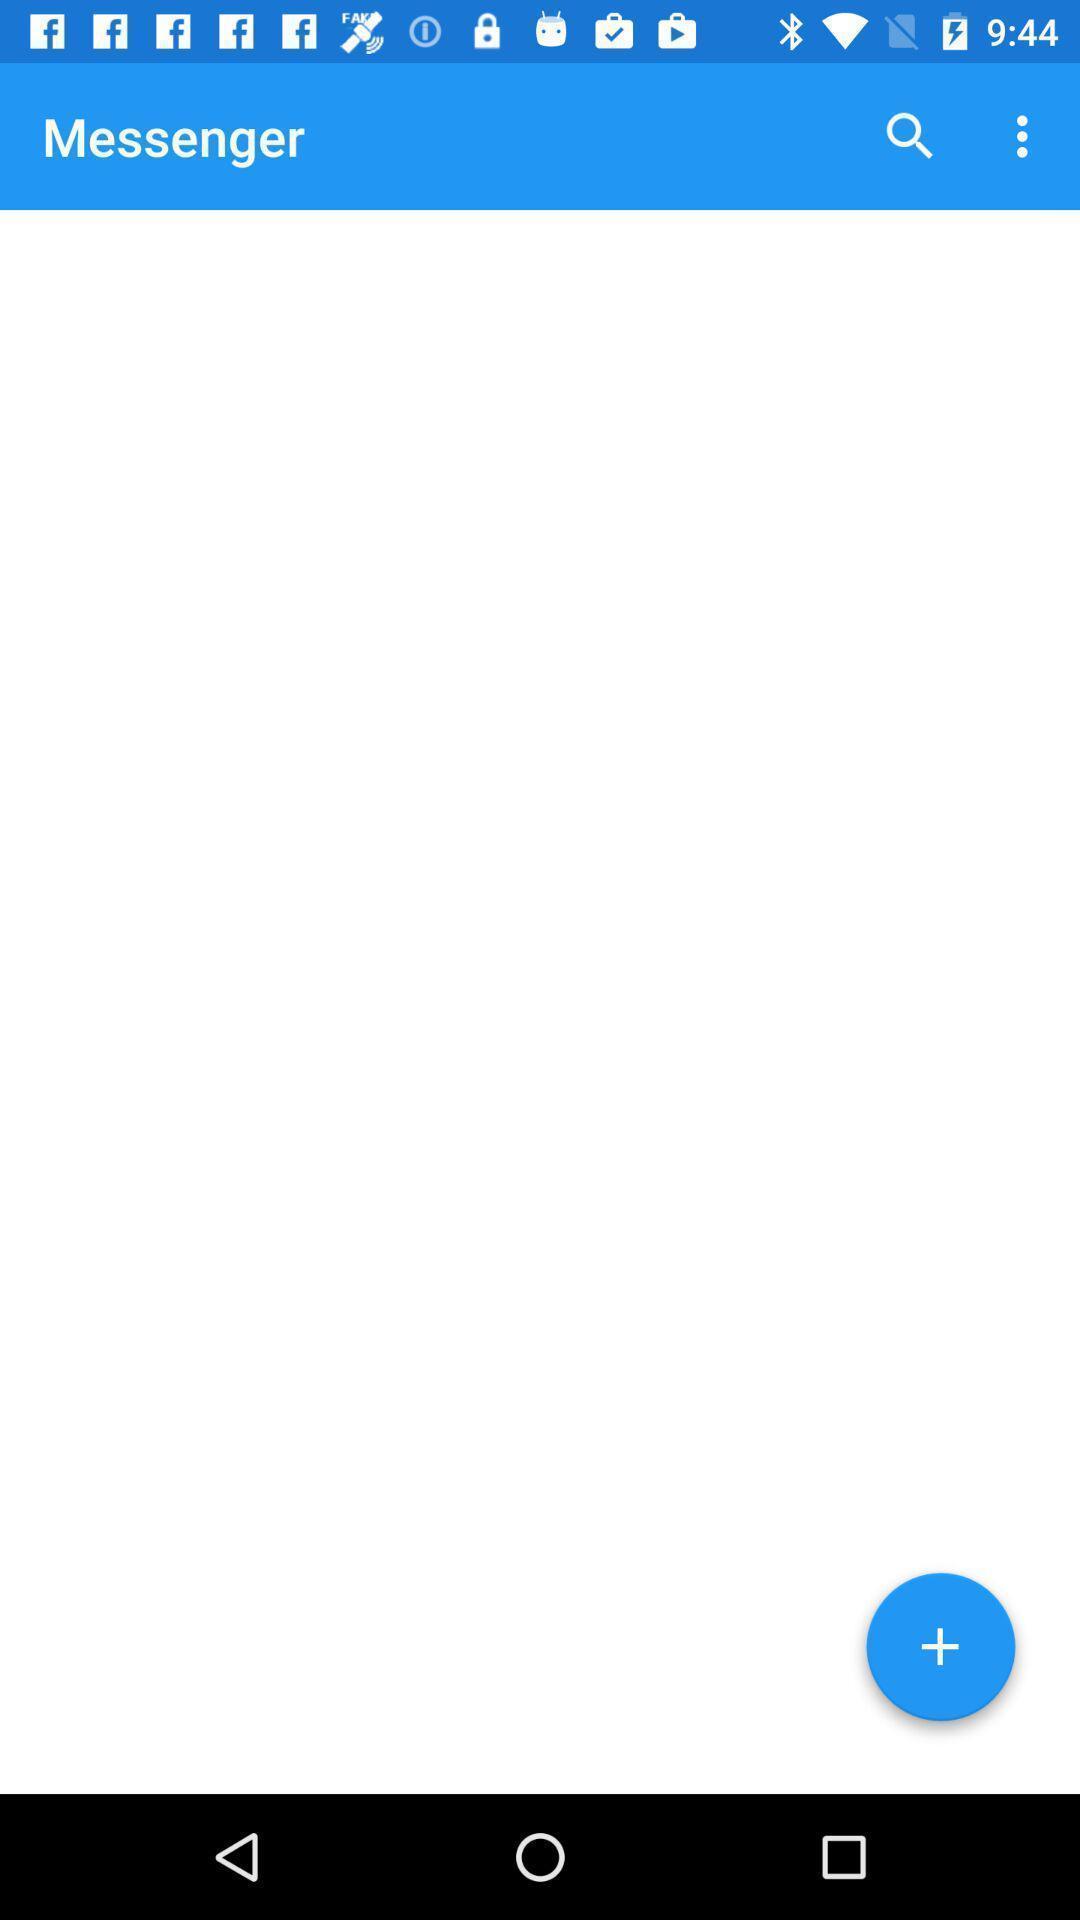Explain what's happening in this screen capture. Screen shows messenger with search option. 